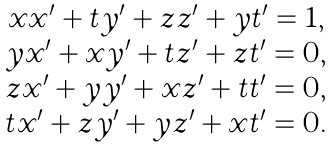<formula> <loc_0><loc_0><loc_500><loc_500>\begin{array} { c } x x ^ { \prime } + t y ^ { \prime } + z z ^ { \prime } + y t ^ { \prime } = 1 , \\ y x ^ { \prime } + x y ^ { \prime } + t z ^ { \prime } + z t ^ { \prime } = 0 , \\ z x ^ { \prime } + y y ^ { \prime } + x z ^ { \prime } + t t ^ { \prime } = 0 , \\ t x ^ { \prime } + z y ^ { \prime } + y z ^ { \prime } + x t ^ { \prime } = 0 . \end{array}</formula> 